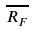Convert formula to latex. <formula><loc_0><loc_0><loc_500><loc_500>\overline { R _ { F } }</formula> 